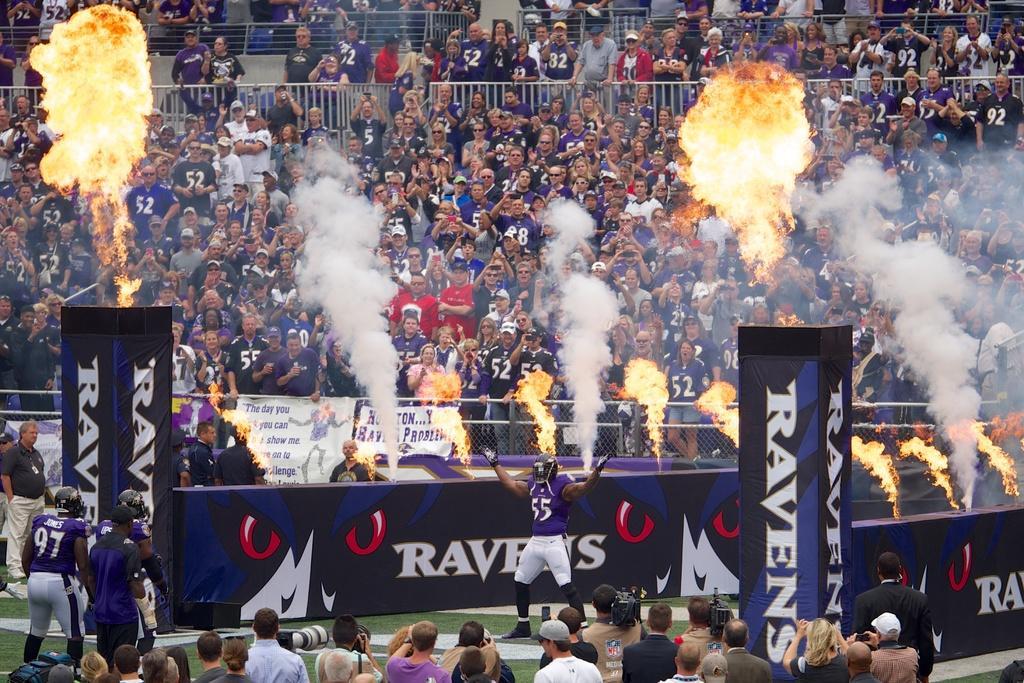Can you describe this image briefly? In the image I can see group of people among them some are standing on the ground and some are standing behind fence. I can also see the fire, white smoke, banners on which something written on it and some other objects on the ground. 